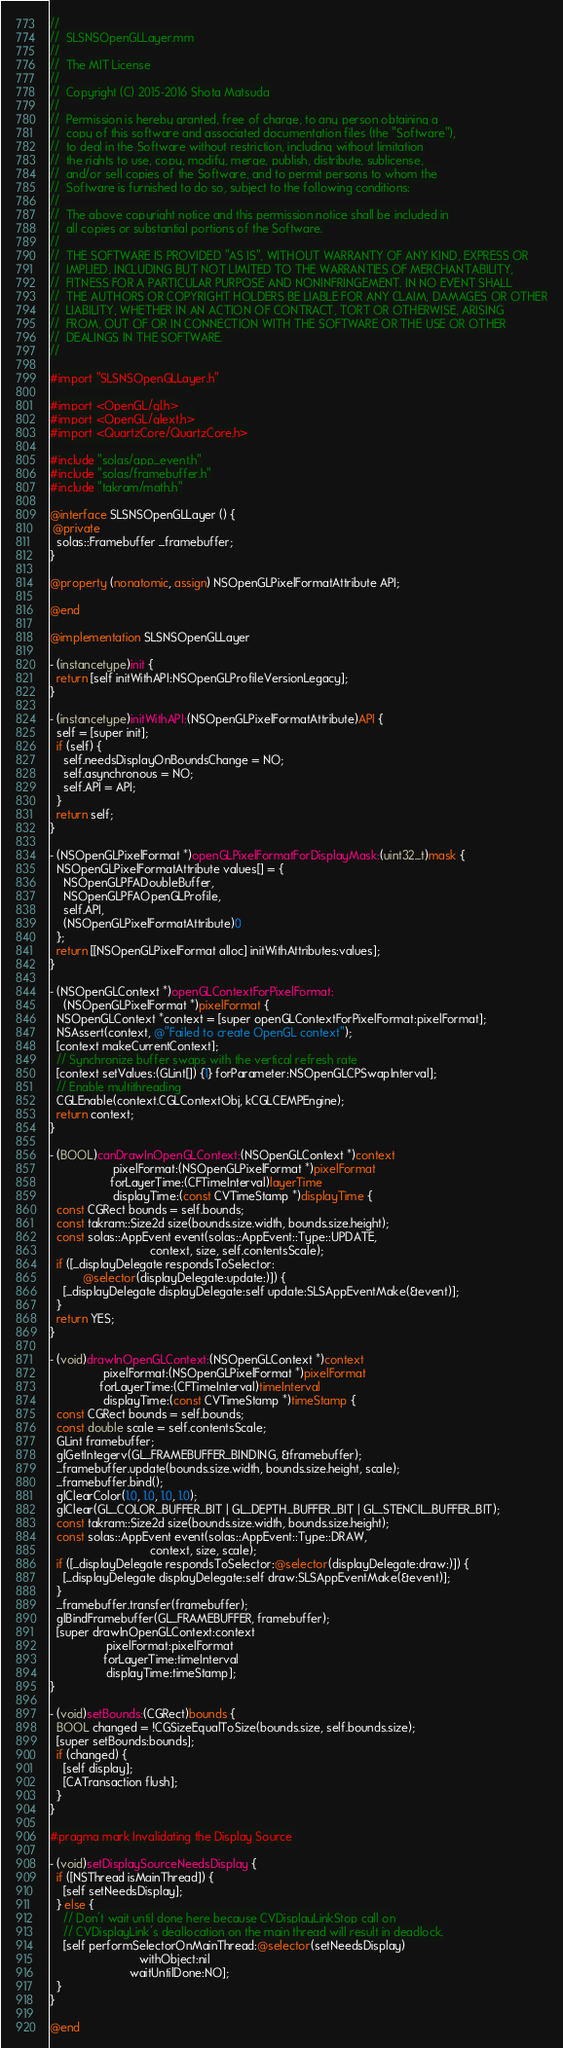<code> <loc_0><loc_0><loc_500><loc_500><_ObjectiveC_>//
//  SLSNSOpenGLLayer.mm
//
//  The MIT License
//
//  Copyright (C) 2015-2016 Shota Matsuda
//
//  Permission is hereby granted, free of charge, to any person obtaining a
//  copy of this software and associated documentation files (the "Software"),
//  to deal in the Software without restriction, including without limitation
//  the rights to use, copy, modify, merge, publish, distribute, sublicense,
//  and/or sell copies of the Software, and to permit persons to whom the
//  Software is furnished to do so, subject to the following conditions:
//
//  The above copyright notice and this permission notice shall be included in
//  all copies or substantial portions of the Software.
//
//  THE SOFTWARE IS PROVIDED "AS IS", WITHOUT WARRANTY OF ANY KIND, EXPRESS OR
//  IMPLIED, INCLUDING BUT NOT LIMITED TO THE WARRANTIES OF MERCHANTABILITY,
//  FITNESS FOR A PARTICULAR PURPOSE AND NONINFRINGEMENT. IN NO EVENT SHALL
//  THE AUTHORS OR COPYRIGHT HOLDERS BE LIABLE FOR ANY CLAIM, DAMAGES OR OTHER
//  LIABILITY, WHETHER IN AN ACTION OF CONTRACT, TORT OR OTHERWISE, ARISING
//  FROM, OUT OF OR IN CONNECTION WITH THE SOFTWARE OR THE USE OR OTHER
//  DEALINGS IN THE SOFTWARE.
//

#import "SLSNSOpenGLLayer.h"

#import <OpenGL/gl.h>
#import <OpenGL/glext.h>
#import <QuartzCore/QuartzCore.h>

#include "solas/app_event.h"
#include "solas/framebuffer.h"
#include "takram/math.h"

@interface SLSNSOpenGLLayer () {
 @private
  solas::Framebuffer _framebuffer;
}

@property (nonatomic, assign) NSOpenGLPixelFormatAttribute API;

@end

@implementation SLSNSOpenGLLayer

- (instancetype)init {
  return [self initWithAPI:NSOpenGLProfileVersionLegacy];
}

- (instancetype)initWithAPI:(NSOpenGLPixelFormatAttribute)API {
  self = [super init];
  if (self) {
    self.needsDisplayOnBoundsChange = NO;
    self.asynchronous = NO;
    self.API = API;
  }
  return self;
}

- (NSOpenGLPixelFormat *)openGLPixelFormatForDisplayMask:(uint32_t)mask {
  NSOpenGLPixelFormatAttribute values[] = {
    NSOpenGLPFADoubleBuffer,
    NSOpenGLPFAOpenGLProfile,
    self.API,
    (NSOpenGLPixelFormatAttribute)0
  };
  return [[NSOpenGLPixelFormat alloc] initWithAttributes:values];
}

- (NSOpenGLContext *)openGLContextForPixelFormat:
    (NSOpenGLPixelFormat *)pixelFormat {
  NSOpenGLContext *context = [super openGLContextForPixelFormat:pixelFormat];
  NSAssert(context, @"Failed to create OpenGL context");
  [context makeCurrentContext];
  // Synchronize buffer swaps with the vertical refresh rate
  [context setValues:(GLint[]) {1} forParameter:NSOpenGLCPSwapInterval];
  // Enable multithreading
  CGLEnable(context.CGLContextObj, kCGLCEMPEngine);
  return context;
}

- (BOOL)canDrawInOpenGLContext:(NSOpenGLContext *)context
                   pixelFormat:(NSOpenGLPixelFormat *)pixelFormat
                  forLayerTime:(CFTimeInterval)layerTime
                   displayTime:(const CVTimeStamp *)displayTime {
  const CGRect bounds = self.bounds;
  const takram::Size2d size(bounds.size.width, bounds.size.height);
  const solas::AppEvent event(solas::AppEvent::Type::UPDATE,
                              context, size, self.contentsScale);
  if ([_displayDelegate respondsToSelector:
          @selector(displayDelegate:update:)]) {
    [_displayDelegate displayDelegate:self update:SLSAppEventMake(&event)];
  }
  return YES;
}

- (void)drawInOpenGLContext:(NSOpenGLContext *)context
                pixelFormat:(NSOpenGLPixelFormat *)pixelFormat
               forLayerTime:(CFTimeInterval)timeInterval
                displayTime:(const CVTimeStamp *)timeStamp {
  const CGRect bounds = self.bounds;
  const double scale = self.contentsScale;
  GLint framebuffer;
  glGetIntegerv(GL_FRAMEBUFFER_BINDING, &framebuffer);
  _framebuffer.update(bounds.size.width, bounds.size.height, scale);
  _framebuffer.bind();
  glClearColor(1.0, 1.0, 1.0, 1.0);
  glClear(GL_COLOR_BUFFER_BIT | GL_DEPTH_BUFFER_BIT | GL_STENCIL_BUFFER_BIT);
  const takram::Size2d size(bounds.size.width, bounds.size.height);
  const solas::AppEvent event(solas::AppEvent::Type::DRAW,
                              context, size, scale);
  if ([_displayDelegate respondsToSelector:@selector(displayDelegate:draw:)]) {
    [_displayDelegate displayDelegate:self draw:SLSAppEventMake(&event)];
  }
  _framebuffer.transfer(framebuffer);
  glBindFramebuffer(GL_FRAMEBUFFER, framebuffer);
  [super drawInOpenGLContext:context
                 pixelFormat:pixelFormat
                forLayerTime:timeInterval
                 displayTime:timeStamp];
}

- (void)setBounds:(CGRect)bounds {
  BOOL changed = !CGSizeEqualToSize(bounds.size, self.bounds.size);
  [super setBounds:bounds];
  if (changed) {
    [self display];
    [CATransaction flush];
  }
}

#pragma mark Invalidating the Display Source

- (void)setDisplaySourceNeedsDisplay {
  if ([NSThread isMainThread]) {
    [self setNeedsDisplay];
  } else {
    // Don't wait until done here because CVDisplayLinkStop call on
    // CVDisplayLink's deallocation on the main thread will result in deadlock.
    [self performSelectorOnMainThread:@selector(setNeedsDisplay)
                           withObject:nil
                        waitUntilDone:NO];
  }
}

@end
</code> 